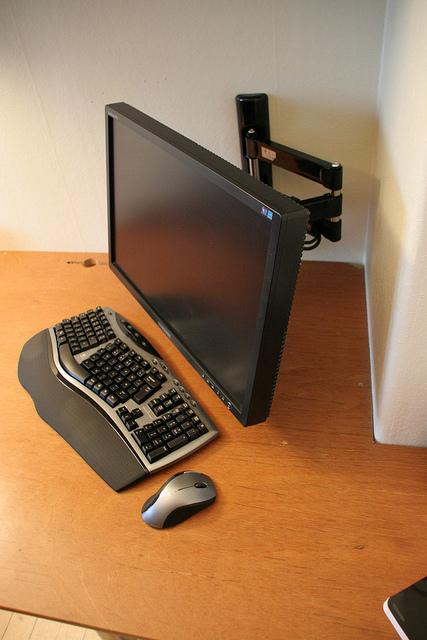What is the mouse next to? keyboard 